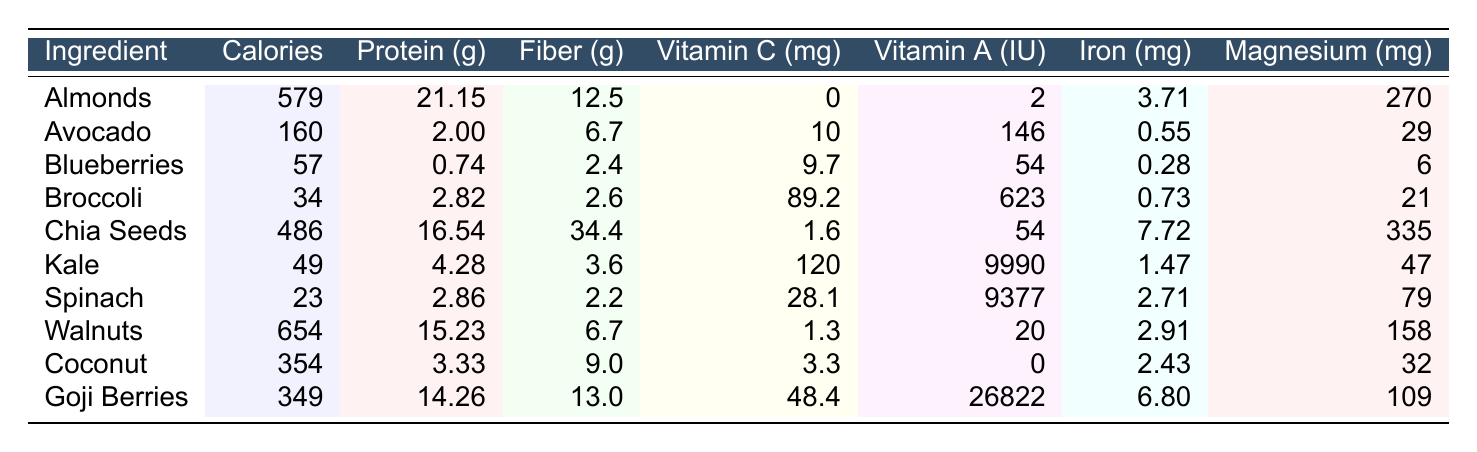What ingredient has the highest calorie content per 100g? By reviewing the table, I can see that Walnuts have the highest calorie content at 654 calories per 100g.
Answer: Walnuts Which ingredient contains the most protein? The table indicates that Chia Seeds provide the most protein, with 16.54 grams per 100g.
Answer: Chia Seeds What is the fiber content of Avocado? The table shows that Avocado contains 6.7 grams of fiber per 100g.
Answer: 6.7 grams How much Vitamin C does Broccoli contain? According to the table, Broccoli contains 89.2 milligrams of Vitamin C per 100g.
Answer: 89.2 mg Which ingredient provides the most Vitamin A? The data reveals that Goji Berries supply the highest amount of Vitamin A at 26822 IU per 100g.
Answer: Goji Berries Is the fiber content of Spinach higher than that of Blueberries? Comparing the two, Spinach has 2.2 grams of fiber, while Blueberries have 2.4 grams. Thus, Spinach's fiber content is lower.
Answer: No What is the combined protein content of Almonds and Walnuts? To find the combined protein, I add the protein from each: Almonds (21.15g) + Walnuts (15.23g) = 36.38g.
Answer: 36.38 grams Which ingredient has the lowest magnesium content? By looking at the table, Spinach has the lowest magnesium content at 79 mg.
Answer: Spinach What is the average Vitamin C content of Kale and Chia Seeds? Kale contains 120 mg and Chia Seeds contain 1.6 mg of Vitamin C. The average is (120 + 1.6) / 2 = 60.8 mg.
Answer: 60.8 mg How much more fiber do Chia Seeds have compared to Broccoli? Chia Seeds have 34.4 grams of fiber, and Broccoli has 2.6 grams. The difference is 34.4 - 2.6 = 31.8 grams.
Answer: 31.8 grams 